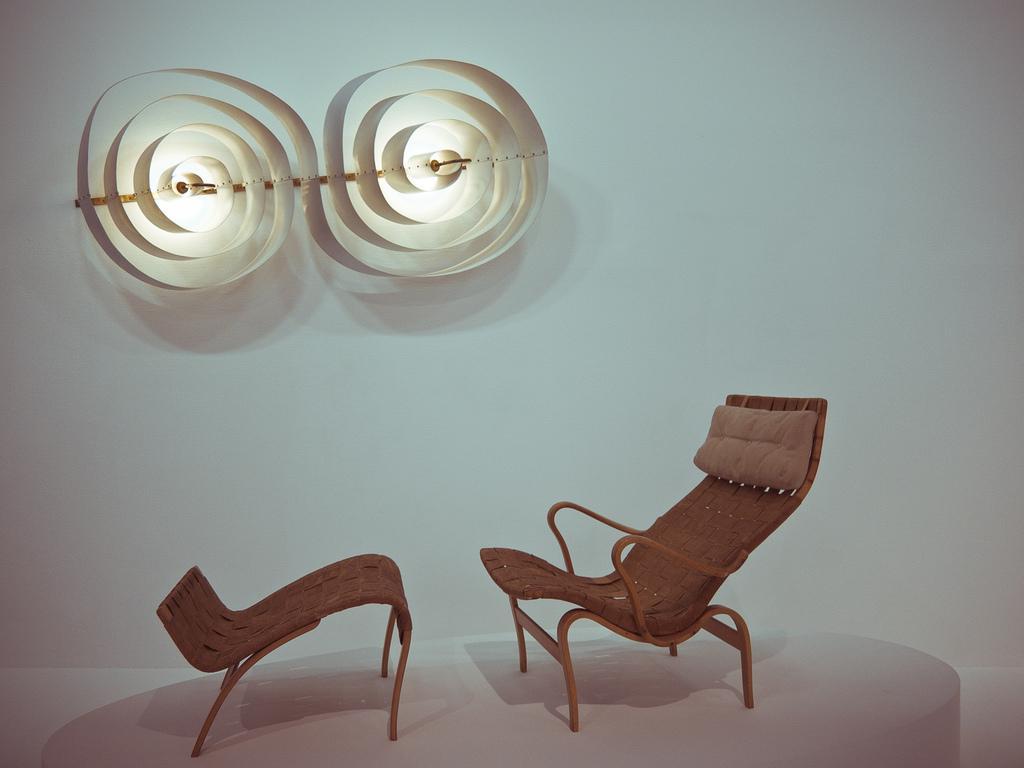Can you describe this image briefly? In this image I can see a chair and a kind of table on the white colour surface. On the top side of the image I can see two lights and designs on the wall. 